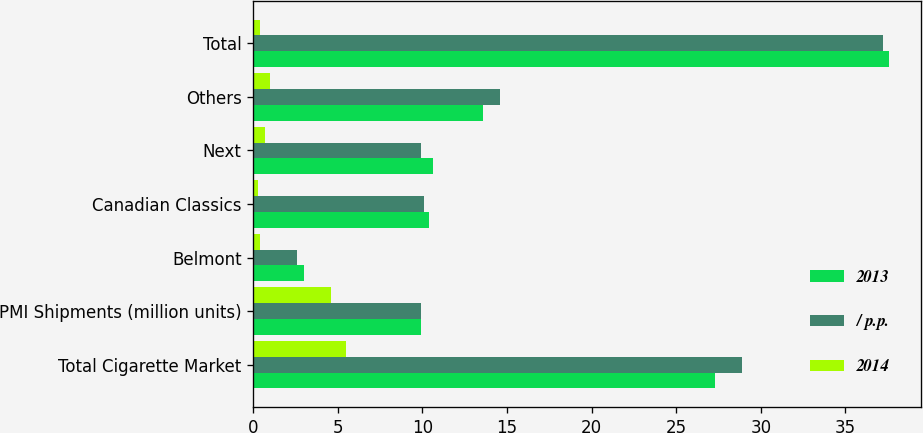Convert chart to OTSL. <chart><loc_0><loc_0><loc_500><loc_500><stacked_bar_chart><ecel><fcel>Total Cigarette Market<fcel>PMI Shipments (million units)<fcel>Belmont<fcel>Canadian Classics<fcel>Next<fcel>Others<fcel>Total<nl><fcel>2013<fcel>27.3<fcel>9.9<fcel>3<fcel>10.4<fcel>10.6<fcel>13.6<fcel>37.6<nl><fcel>/ p.p.<fcel>28.9<fcel>9.9<fcel>2.6<fcel>10.1<fcel>9.9<fcel>14.6<fcel>37.2<nl><fcel>2014<fcel>5.5<fcel>4.6<fcel>0.4<fcel>0.3<fcel>0.7<fcel>1<fcel>0.4<nl></chart> 